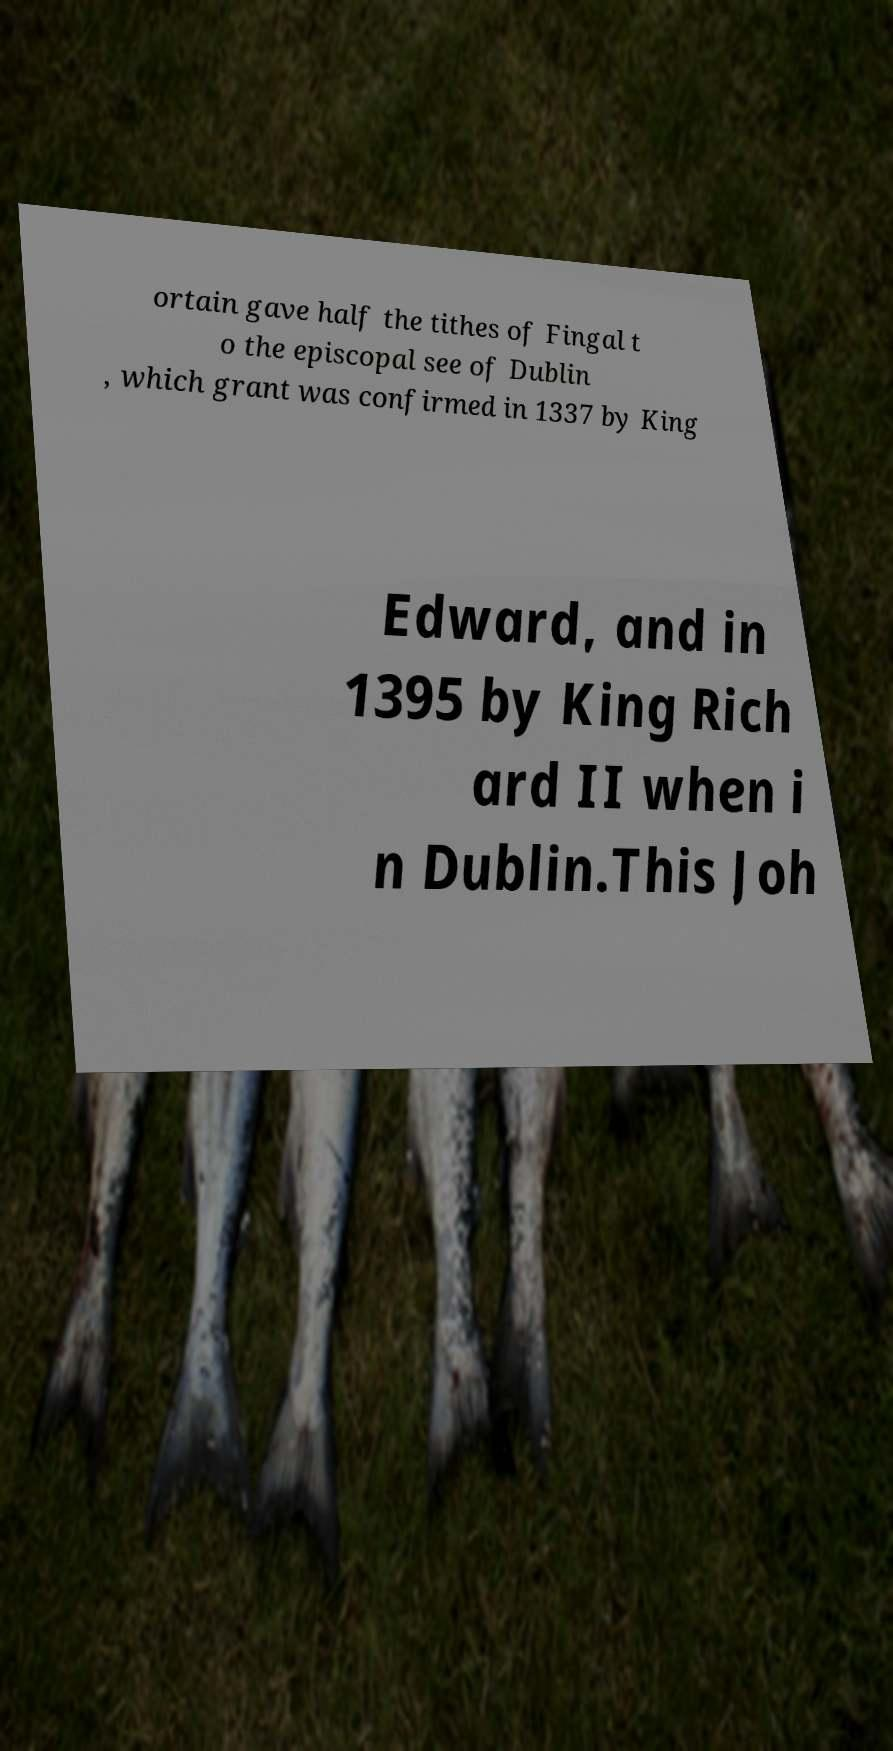What messages or text are displayed in this image? I need them in a readable, typed format. ortain gave half the tithes of Fingal t o the episcopal see of Dublin , which grant was confirmed in 1337 by King Edward, and in 1395 by King Rich ard II when i n Dublin.This Joh 